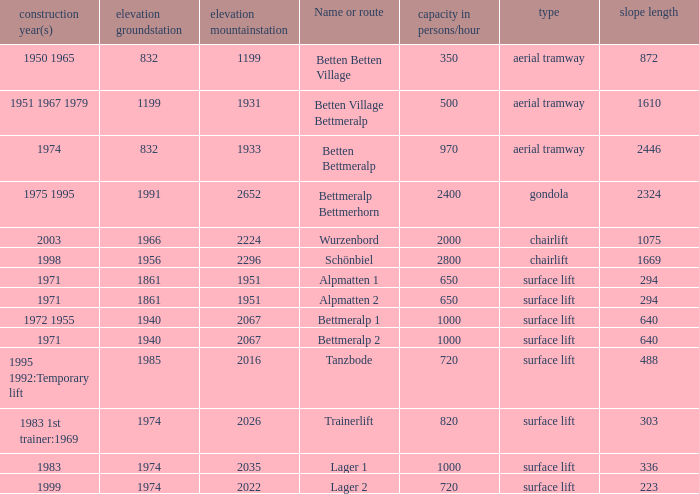Which elevation groundstation has a capacity in persons/hour larger than 820, and a Name or route of lager 1, and a slope length smaller than 336? None. 